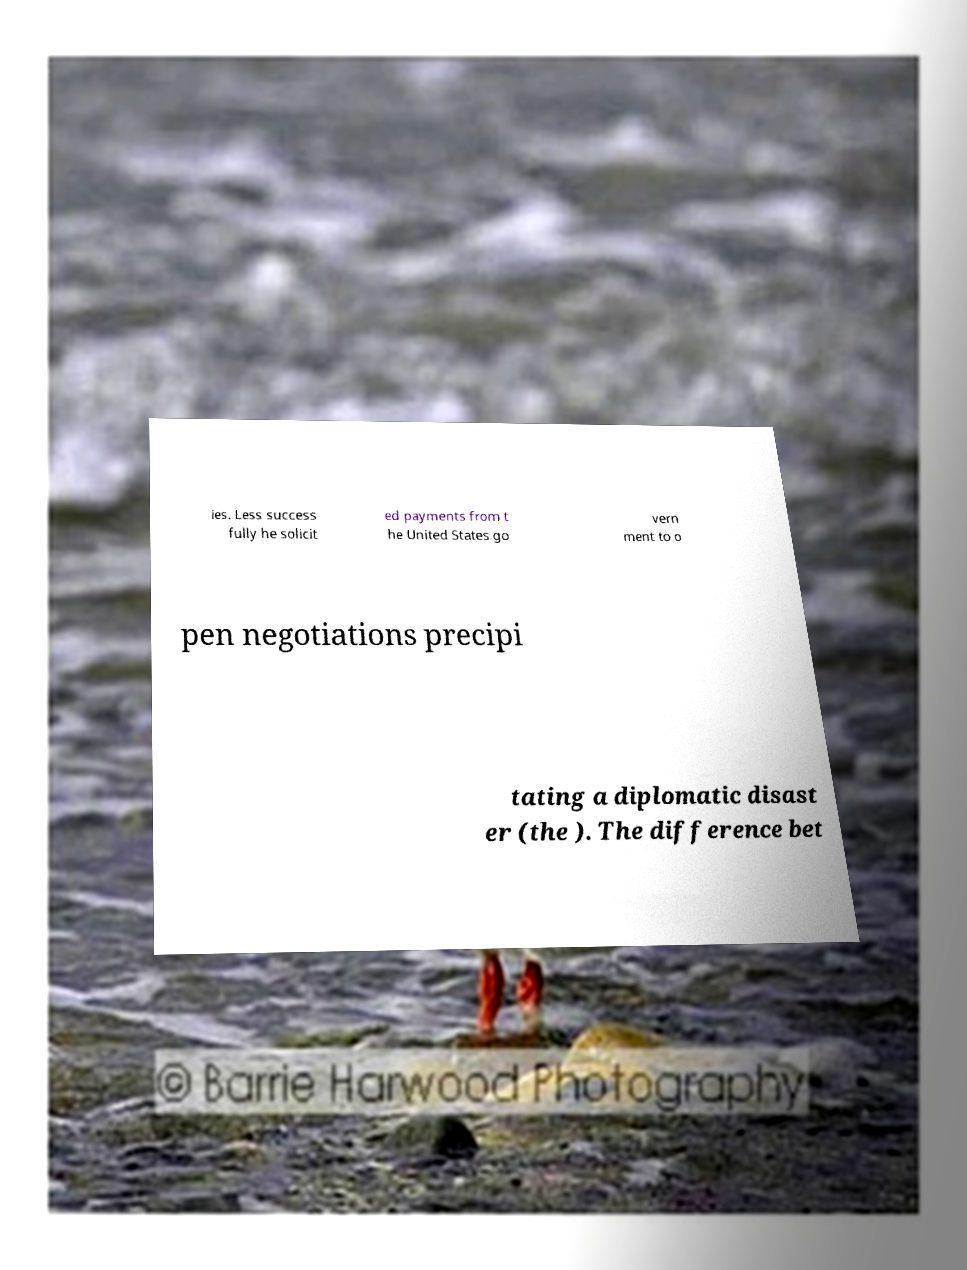Please read and relay the text visible in this image. What does it say? ies. Less success fully he solicit ed payments from t he United States go vern ment to o pen negotiations precipi tating a diplomatic disast er (the ). The difference bet 